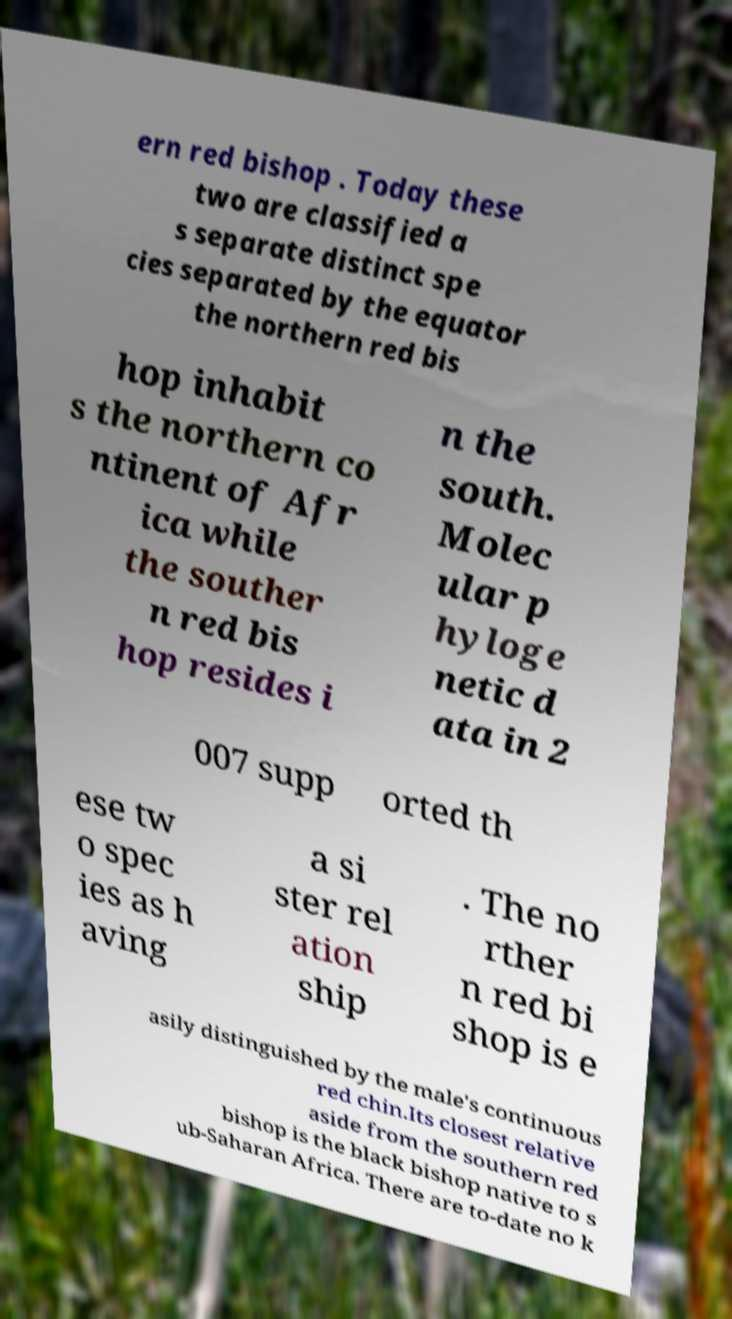What messages or text are displayed in this image? I need them in a readable, typed format. ern red bishop . Today these two are classified a s separate distinct spe cies separated by the equator the northern red bis hop inhabit s the northern co ntinent of Afr ica while the souther n red bis hop resides i n the south. Molec ular p hyloge netic d ata in 2 007 supp orted th ese tw o spec ies as h aving a si ster rel ation ship . The no rther n red bi shop is e asily distinguished by the male's continuous red chin.Its closest relative aside from the southern red bishop is the black bishop native to s ub-Saharan Africa. There are to-date no k 